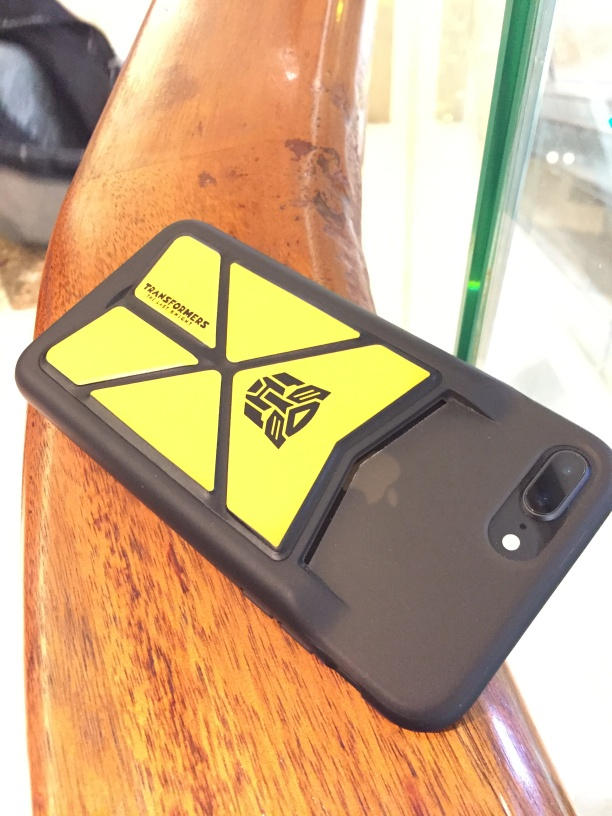How could you interpret the choice of this specific phone case style for the user? The selection of a phone case with a distinctive and eye-catching emblem could be an expression of the user's personality or interests. Perhaps they are fans of a particular brand or franchise that the logo represents, or they simply appreciate graphically bold and geometric designs. 